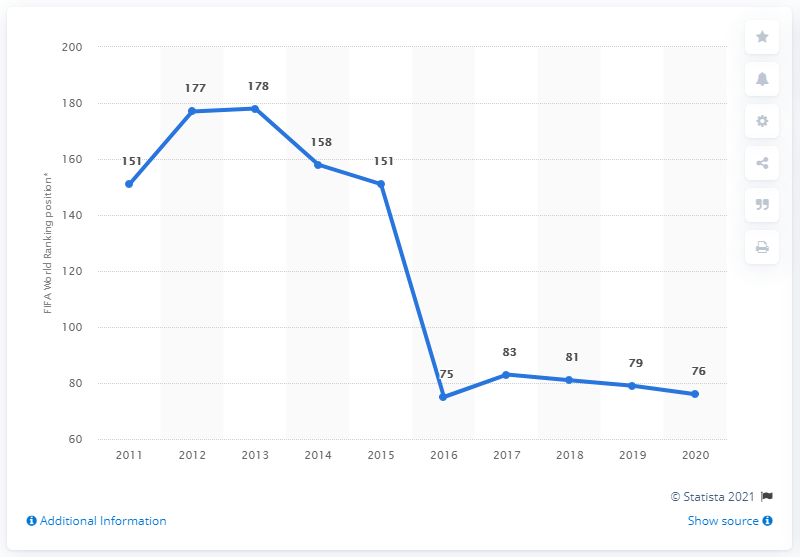Highlight a few significant elements in this photo. The ranking of the Curaçao national football team improved from 76 in 2015 to 75 in 2016. The Curaçao national football team had a FIFA World Ranking of 83 in the year 2017. 